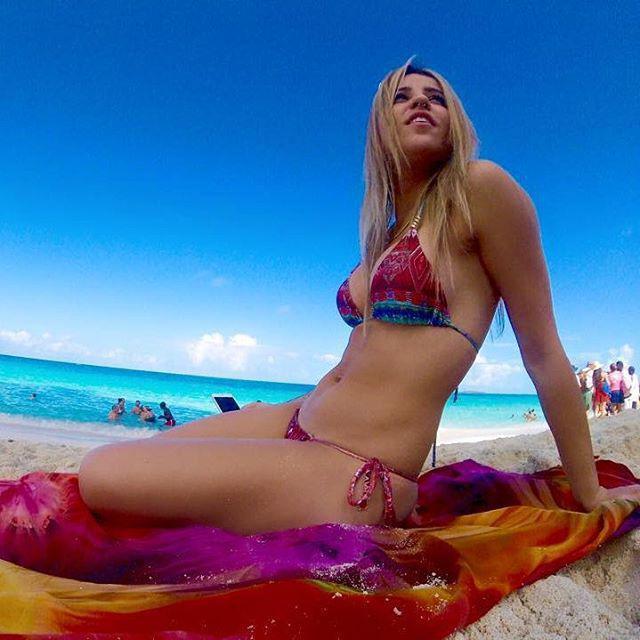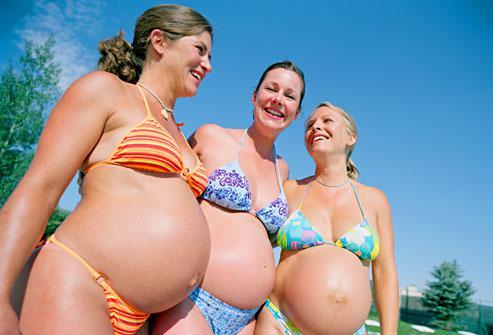The first image is the image on the left, the second image is the image on the right. Considering the images on both sides, is "There is a female wearing a pink bikini in the right image." valid? Answer yes or no. No. The first image is the image on the left, the second image is the image on the right. Assess this claim about the two images: "One of the images shows exactly one woman sitting at the beach wearing a bikini.". Correct or not? Answer yes or no. Yes. 